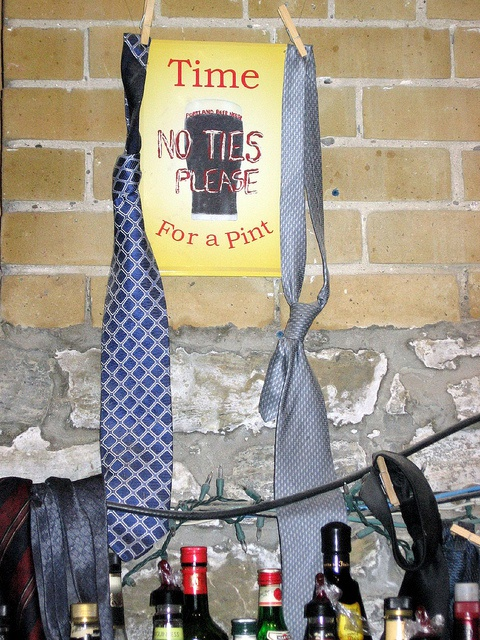Describe the objects in this image and their specific colors. I can see tie in olive, blue, navy, lightgray, and darkgray tones, tie in olive, darkgray, and gray tones, tie in olive, black, gray, darkgray, and tan tones, tie in olive, darkgray, and gray tones, and tie in olive, black, maroon, gray, and darkgray tones in this image. 